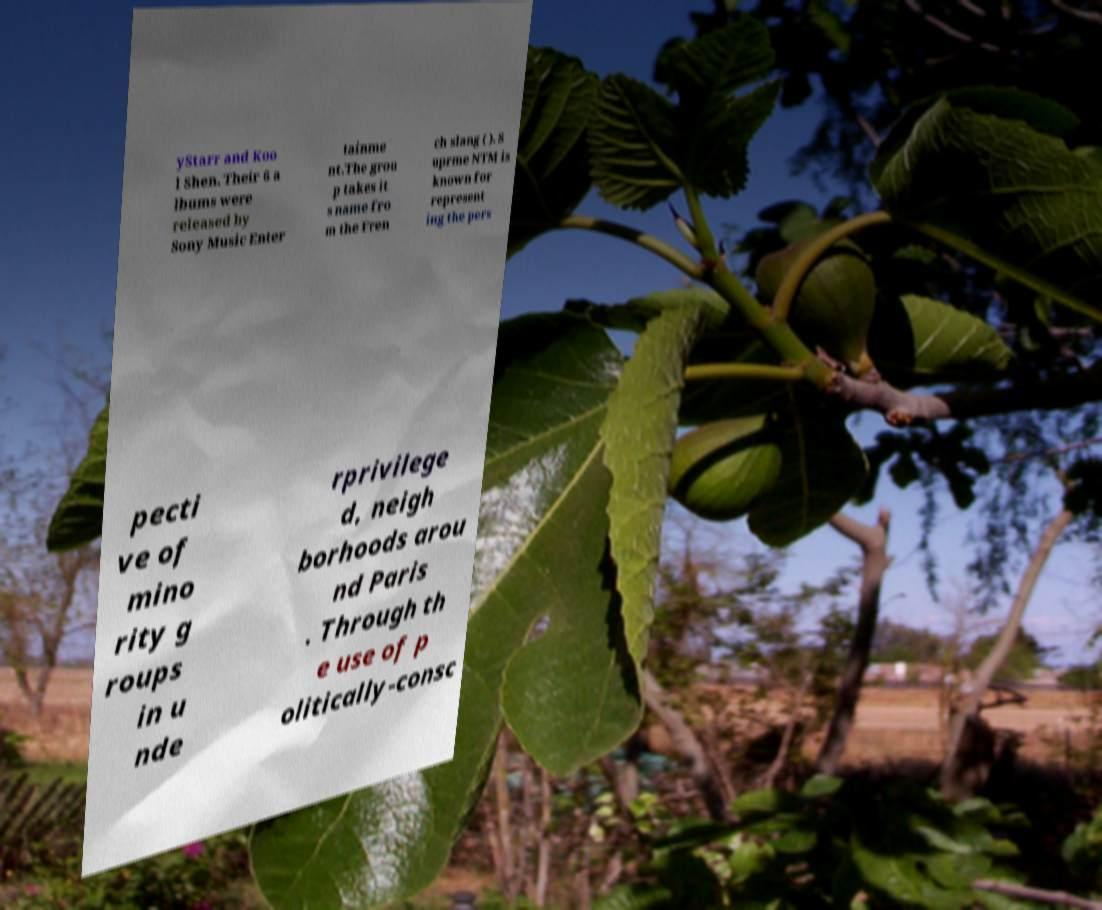Could you assist in decoding the text presented in this image and type it out clearly? yStarr and Koo l Shen. Their 6 a lbums were released by Sony Music Enter tainme nt.The grou p takes it s name fro m the Fren ch slang ( ). S uprme NTM is known for represent ing the pers pecti ve of mino rity g roups in u nde rprivilege d, neigh borhoods arou nd Paris . Through th e use of p olitically-consc 